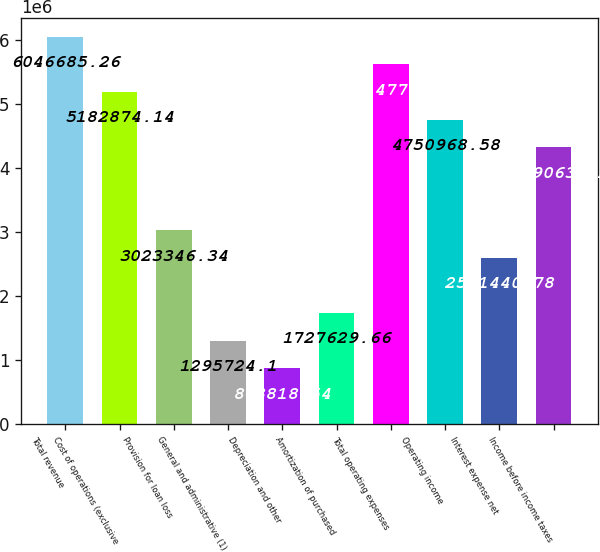<chart> <loc_0><loc_0><loc_500><loc_500><bar_chart><fcel>Total revenue<fcel>Cost of operations (exclusive<fcel>Provision for loan loss<fcel>General and administrative (1)<fcel>Depreciation and other<fcel>Amortization of purchased<fcel>Total operating expenses<fcel>Operating income<fcel>Interest expense net<fcel>Income before income taxes<nl><fcel>6.04669e+06<fcel>5.18287e+06<fcel>3.02335e+06<fcel>1.29572e+06<fcel>863819<fcel>1.72763e+06<fcel>5.61478e+06<fcel>4.75097e+06<fcel>2.59144e+06<fcel>4.31906e+06<nl></chart> 